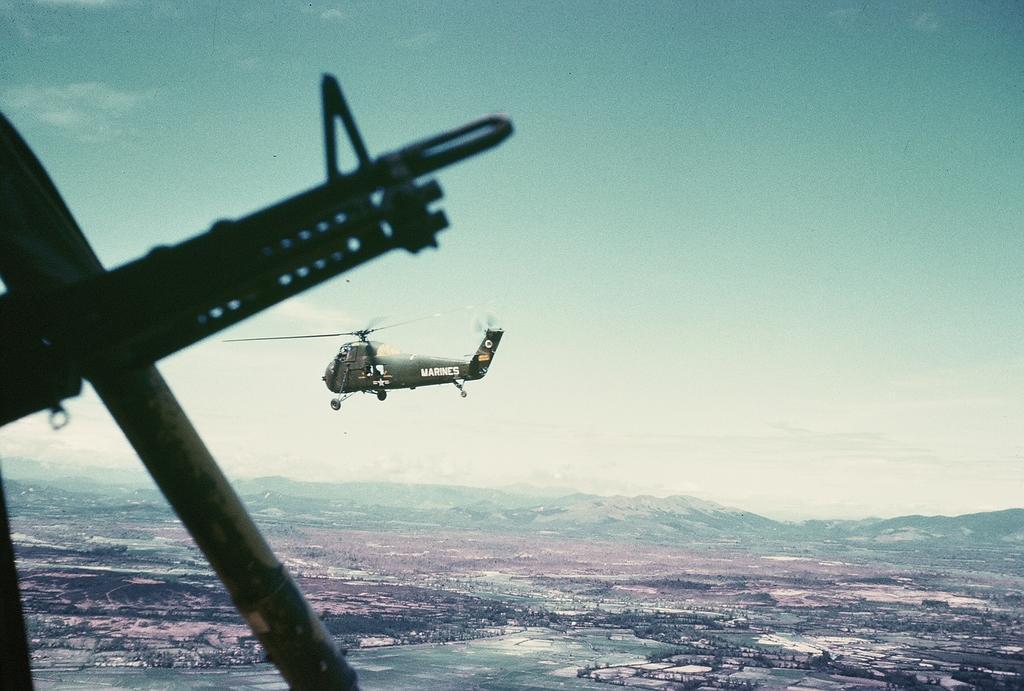Describe this image in one or two sentences. In the picture we can see weapon on left side, there is a helicopter which is flying in the sky and we can see aerial view and in the background of the picture there are some mountains and top of the picture there is clear sky. 